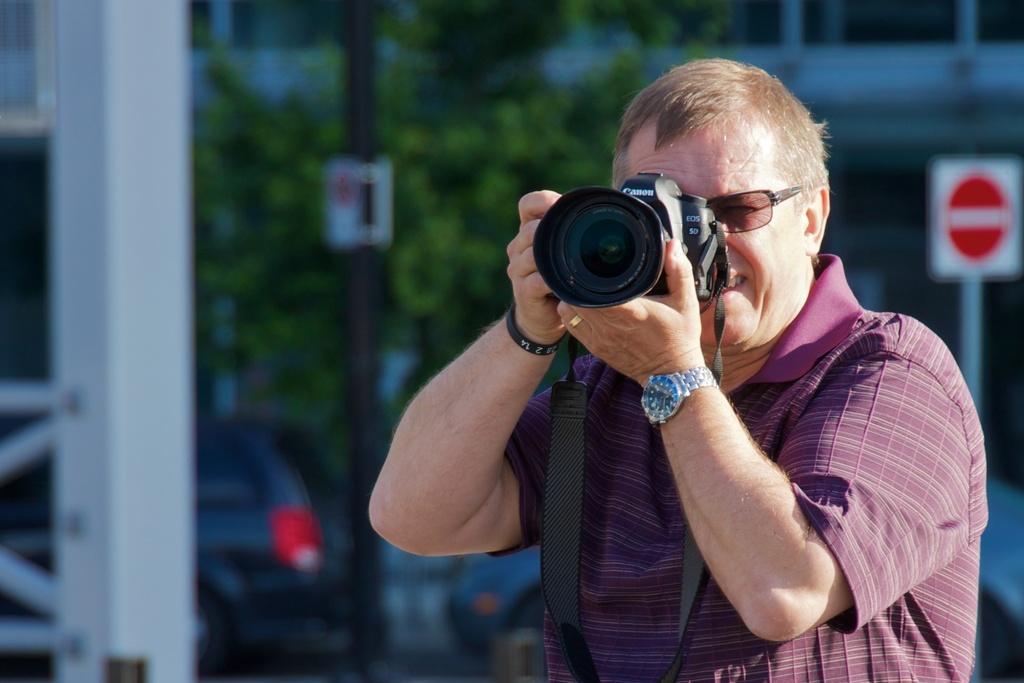Describe this image in one or two sentences. In this image, In the right side there is a man standing and he is holding a camera which is in black color and he is taking a picture, In the background there is a green color tree and in the left side there is a white color pole. 